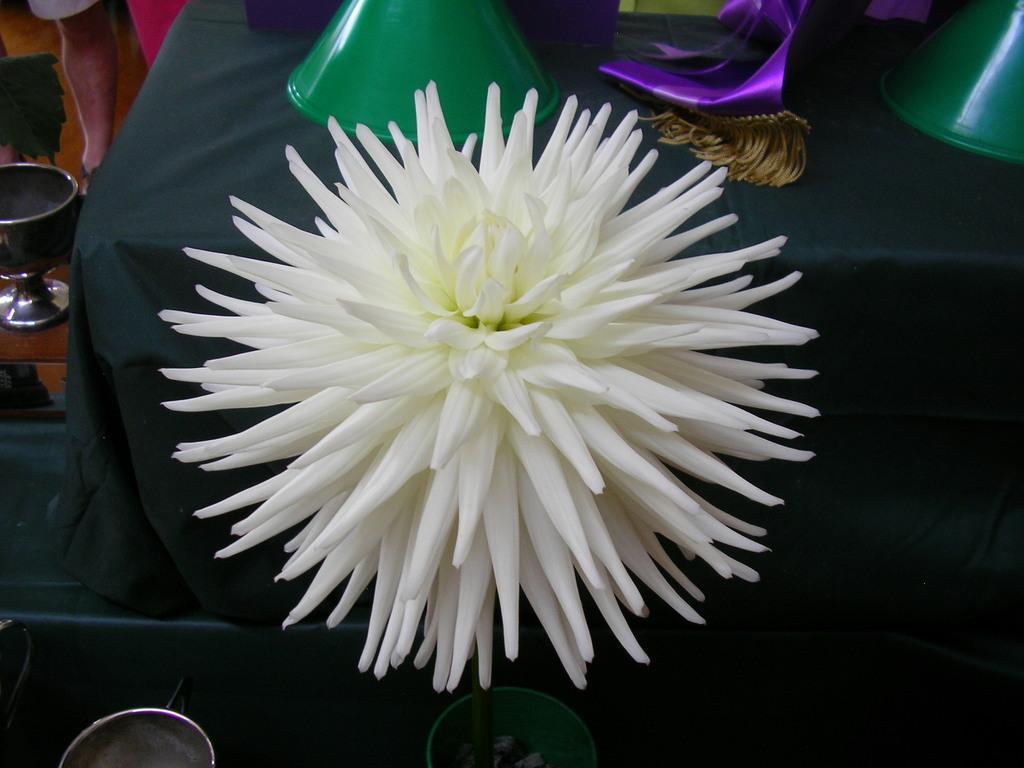How would you summarize this image in a sentence or two? In this picture I can see a flower in the middle, at the top there are plastic things on a table. 